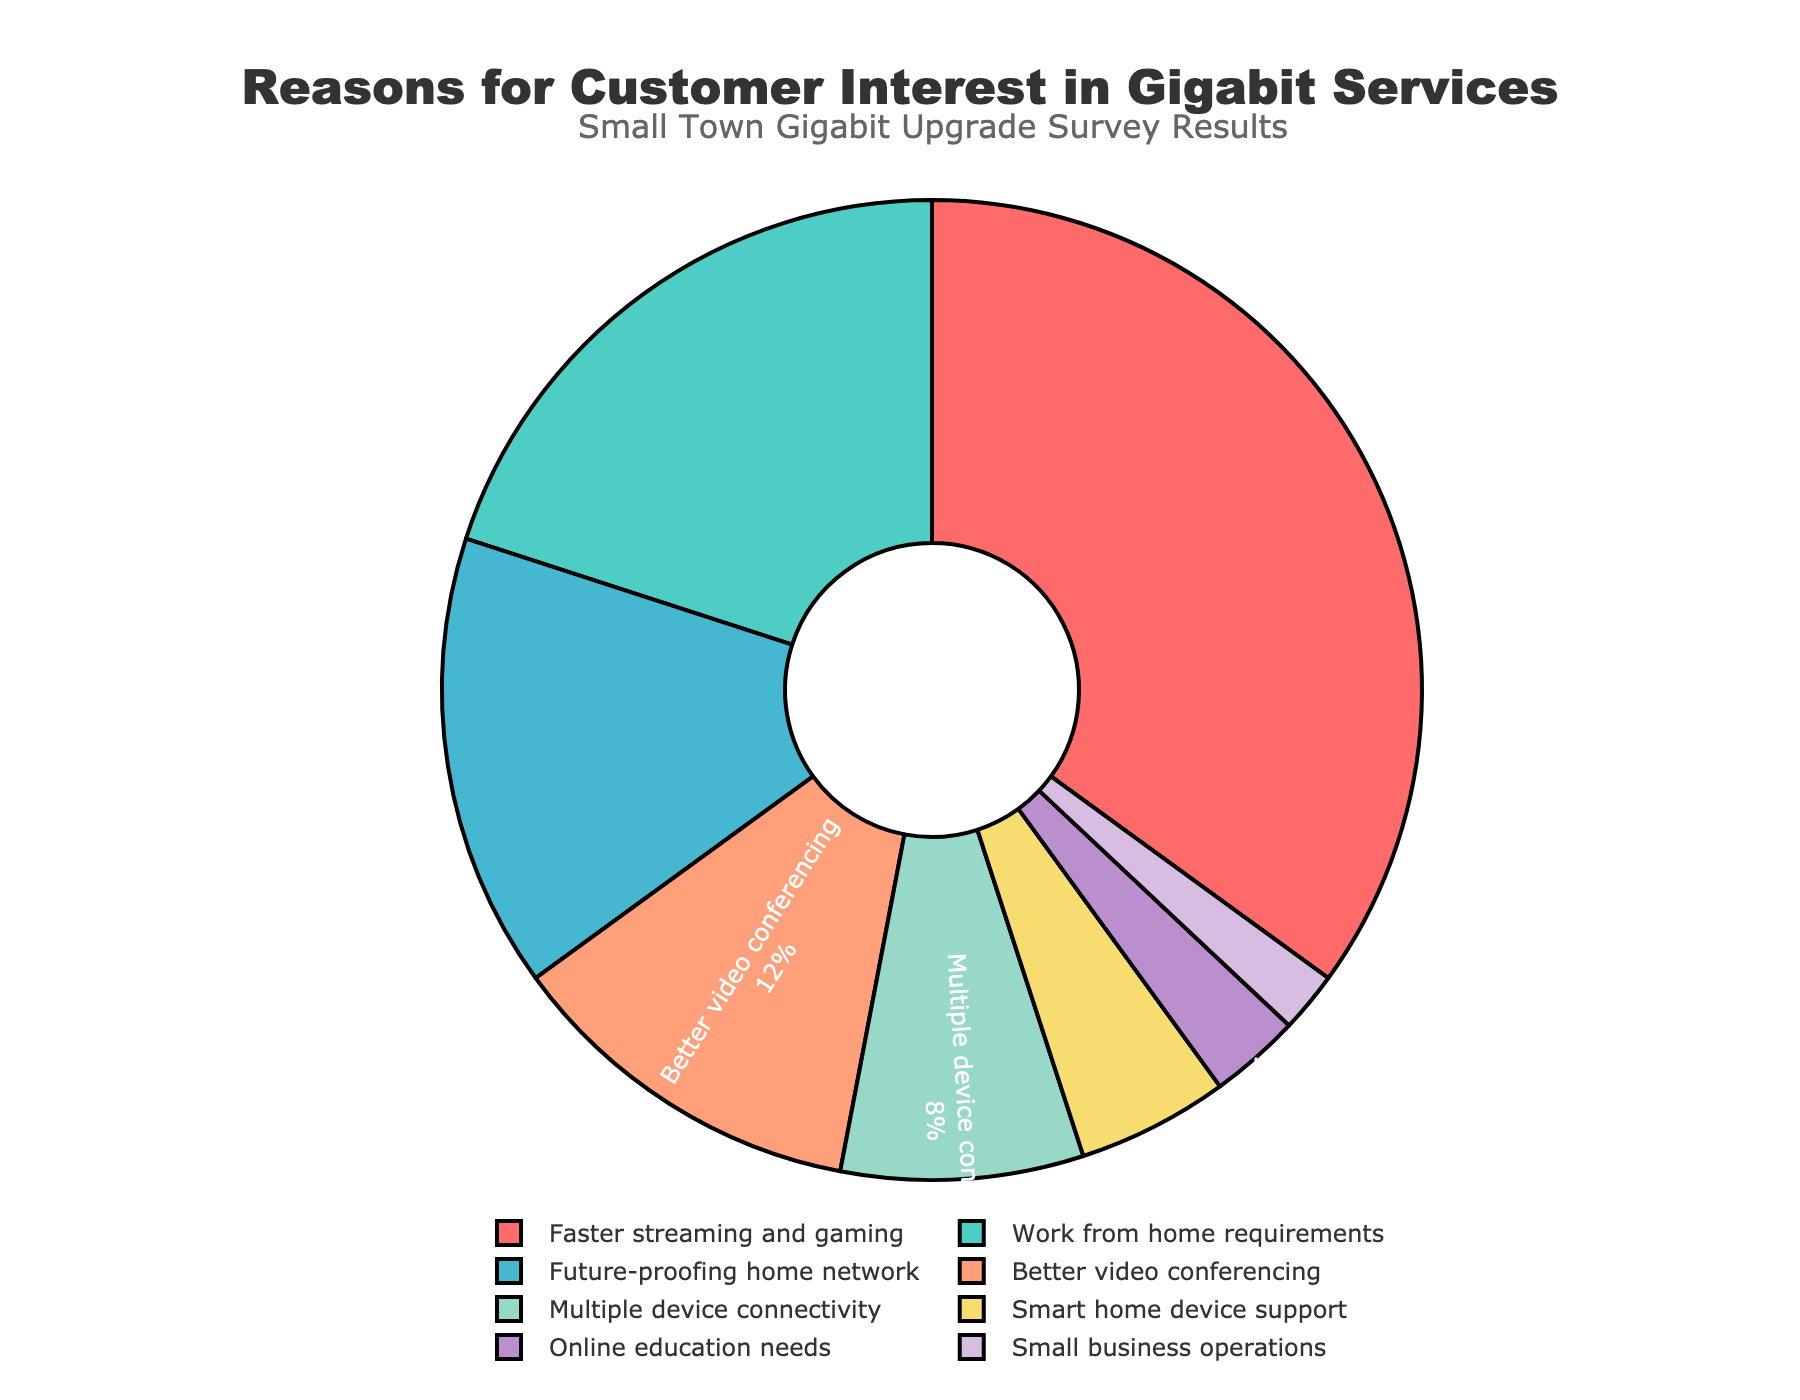What is the most common reason for customer interest in upgrading to Gigabit services? The pie chart shows the largest slice correlating to "Faster streaming and gaming," which accounts for 35% of the total responses.
Answer: Faster streaming and gaming Which two reasons combined make up more than half of the total customer interest? Combining "Faster streaming and gaming" (35%) and "Work from home requirements" (20%) results in 55%, which is more than half of the total percentage.
Answer: Faster streaming and gaming and Work from home requirements What is the combined percentage for "Better video conferencing" and "Multiple device connectivity"? The pie chart indicates "Better video conferencing" is 12% and "Multiple device connectivity" is 8%. Adding these together: 12% + 8% = 20%.
Answer: 20% Is there a reason related to small business operations, and if so, what is its percentage? The pie chart includes a segment labeled "Small business operations" which represents 2% of the total.
Answer: Yes, 2% Which reason has a smaller percentage: "Future-proofing home network" or "Smart home device support"? Comparing the segments, "Future-proofing home network" accounts for 15%, while "Smart home device support" accounts for 5%. Therefore, "Smart home device support" has a smaller percentage.
Answer: Smart home device support What percentage gap exists between "Work from home requirements" and "Online education needs"? "Work from home requirements" is 20% and "Online education needs" is 3%. The difference between them is 20% - 3% = 17%.
Answer: 17% What is the total percentage represented by all reasons except "Faster streaming and gaming"? Subtracting the percentage of "Faster streaming and gaming" from 100%: 100% - 35% = 65%.
Answer: 65% Which color represents the reason "Faster streaming and gaming"? By observing the pie chart, "Faster streaming and gaming" is represented by the red color.
Answer: Red How does the segment for "Smart home device support" compare visually to the segment for "Future-proofing home network"? The slice representing "Smart home device support" is smaller in size compared to the slice for "Future-proofing home network," indicating a lower percentage.
Answer: Smaller What visual attribute makes the pie chart easy to interpret different segments? The use of distinct colors and clear labeling with percentages inside each slice allows easy differentiation and interpretation of each segment.
Answer: Distinct colors and clear labeling 